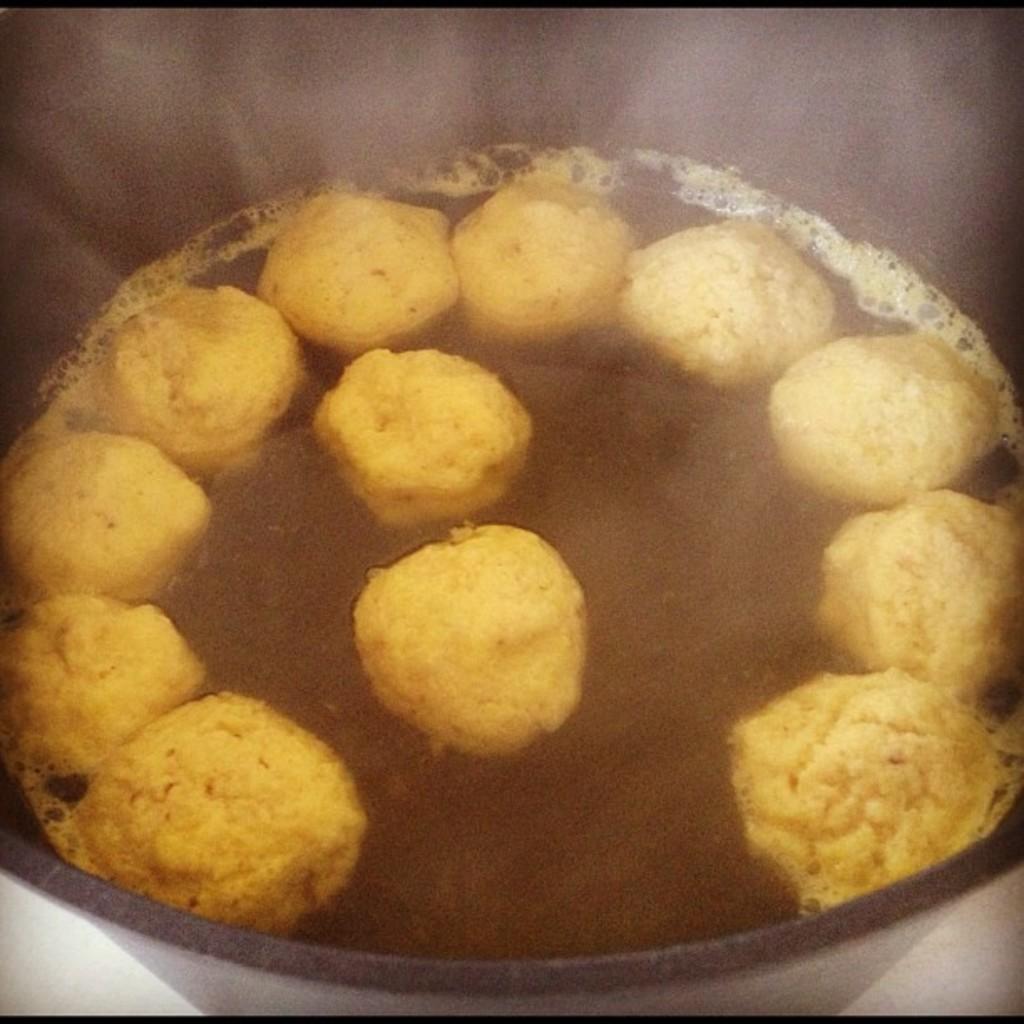Can you describe this image briefly? As we can see in the image there is bowl. In bowl there is food item. 